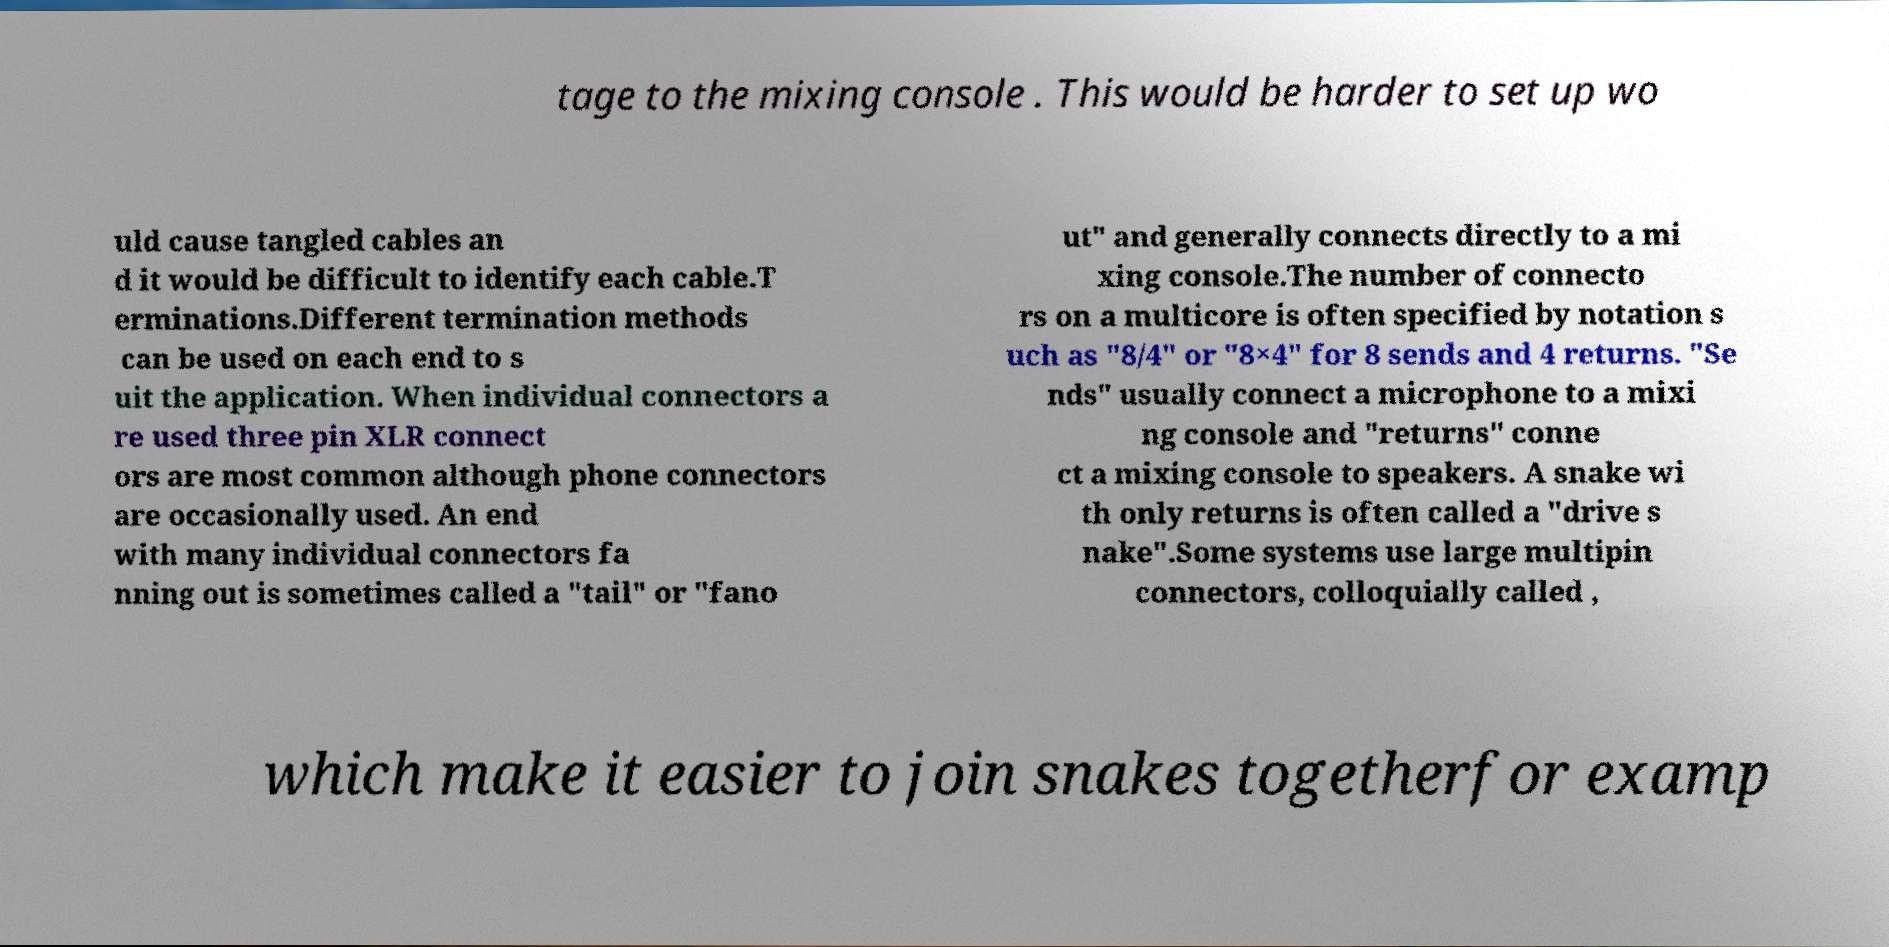What messages or text are displayed in this image? I need them in a readable, typed format. tage to the mixing console . This would be harder to set up wo uld cause tangled cables an d it would be difficult to identify each cable.T erminations.Different termination methods can be used on each end to s uit the application. When individual connectors a re used three pin XLR connect ors are most common although phone connectors are occasionally used. An end with many individual connectors fa nning out is sometimes called a "tail" or "fano ut" and generally connects directly to a mi xing console.The number of connecto rs on a multicore is often specified by notation s uch as "8/4" or "8×4" for 8 sends and 4 returns. "Se nds" usually connect a microphone to a mixi ng console and "returns" conne ct a mixing console to speakers. A snake wi th only returns is often called a "drive s nake".Some systems use large multipin connectors, colloquially called , which make it easier to join snakes togetherfor examp 